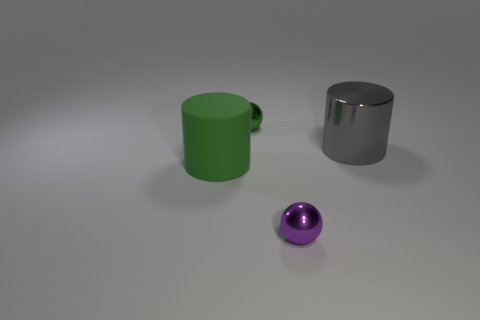Are there any other things that are the same material as the green cylinder?
Keep it short and to the point. No. What shape is the big green matte thing?
Offer a very short reply. Cylinder. What shape is the other thing that is the same size as the gray object?
Ensure brevity in your answer.  Cylinder. What number of other things are there of the same color as the large metal cylinder?
Your answer should be very brief. 0. Is the shape of the big thing behind the matte object the same as the large thing left of the shiny cylinder?
Ensure brevity in your answer.  Yes. What number of objects are either shiny spheres behind the big metallic cylinder or things that are in front of the tiny green metallic thing?
Make the answer very short. 4. How many other objects are the same material as the big gray object?
Provide a succinct answer. 2. Does the sphere that is in front of the green rubber thing have the same material as the small green object?
Offer a terse response. Yes. Are there more spheres in front of the tiny green metallic sphere than purple objects in front of the small purple metal object?
Give a very brief answer. Yes. How many objects are large cylinders on the left side of the shiny cylinder or rubber objects?
Your answer should be very brief. 1. 